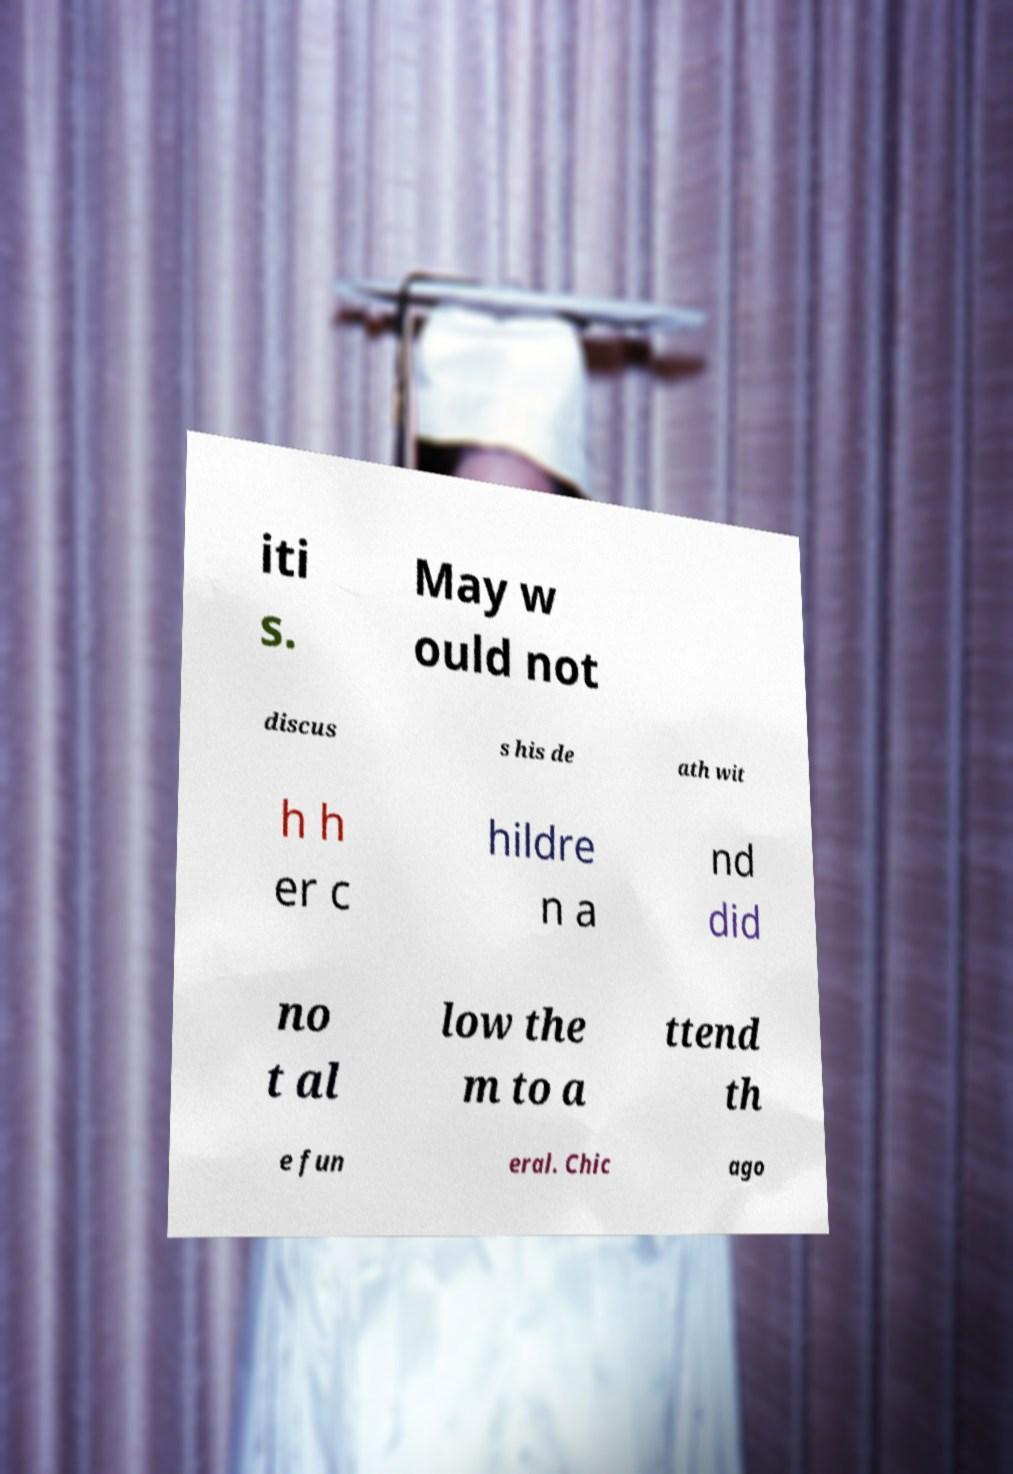Please identify and transcribe the text found in this image. iti s. May w ould not discus s his de ath wit h h er c hildre n a nd did no t al low the m to a ttend th e fun eral. Chic ago 